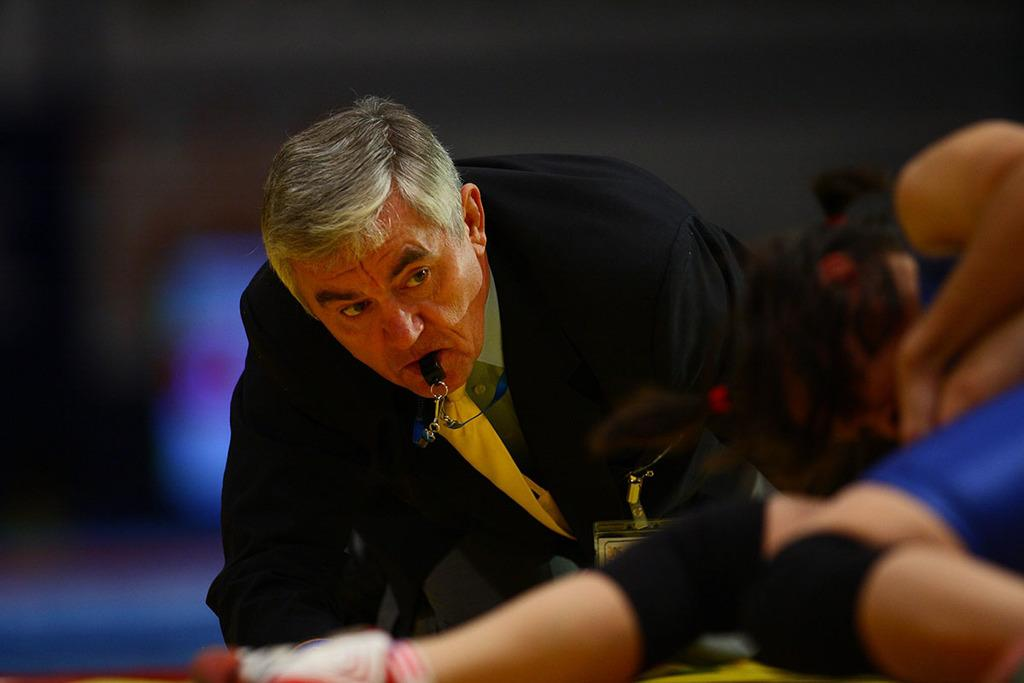Who is the main subject in the image? There is a man in the image. What is the man doing in the image? The man has a whistle in his mouth. Are there any other people in the image? Yes, there is another person in the image. Can you describe the background of the image? The background of the image is blurred. What type of owl can be seen in the image? There is no owl present in the image. How far away is the achiever from the camera in the image? The term "achiever" is not mentioned in the facts, and there is no reference to distance in the image. 